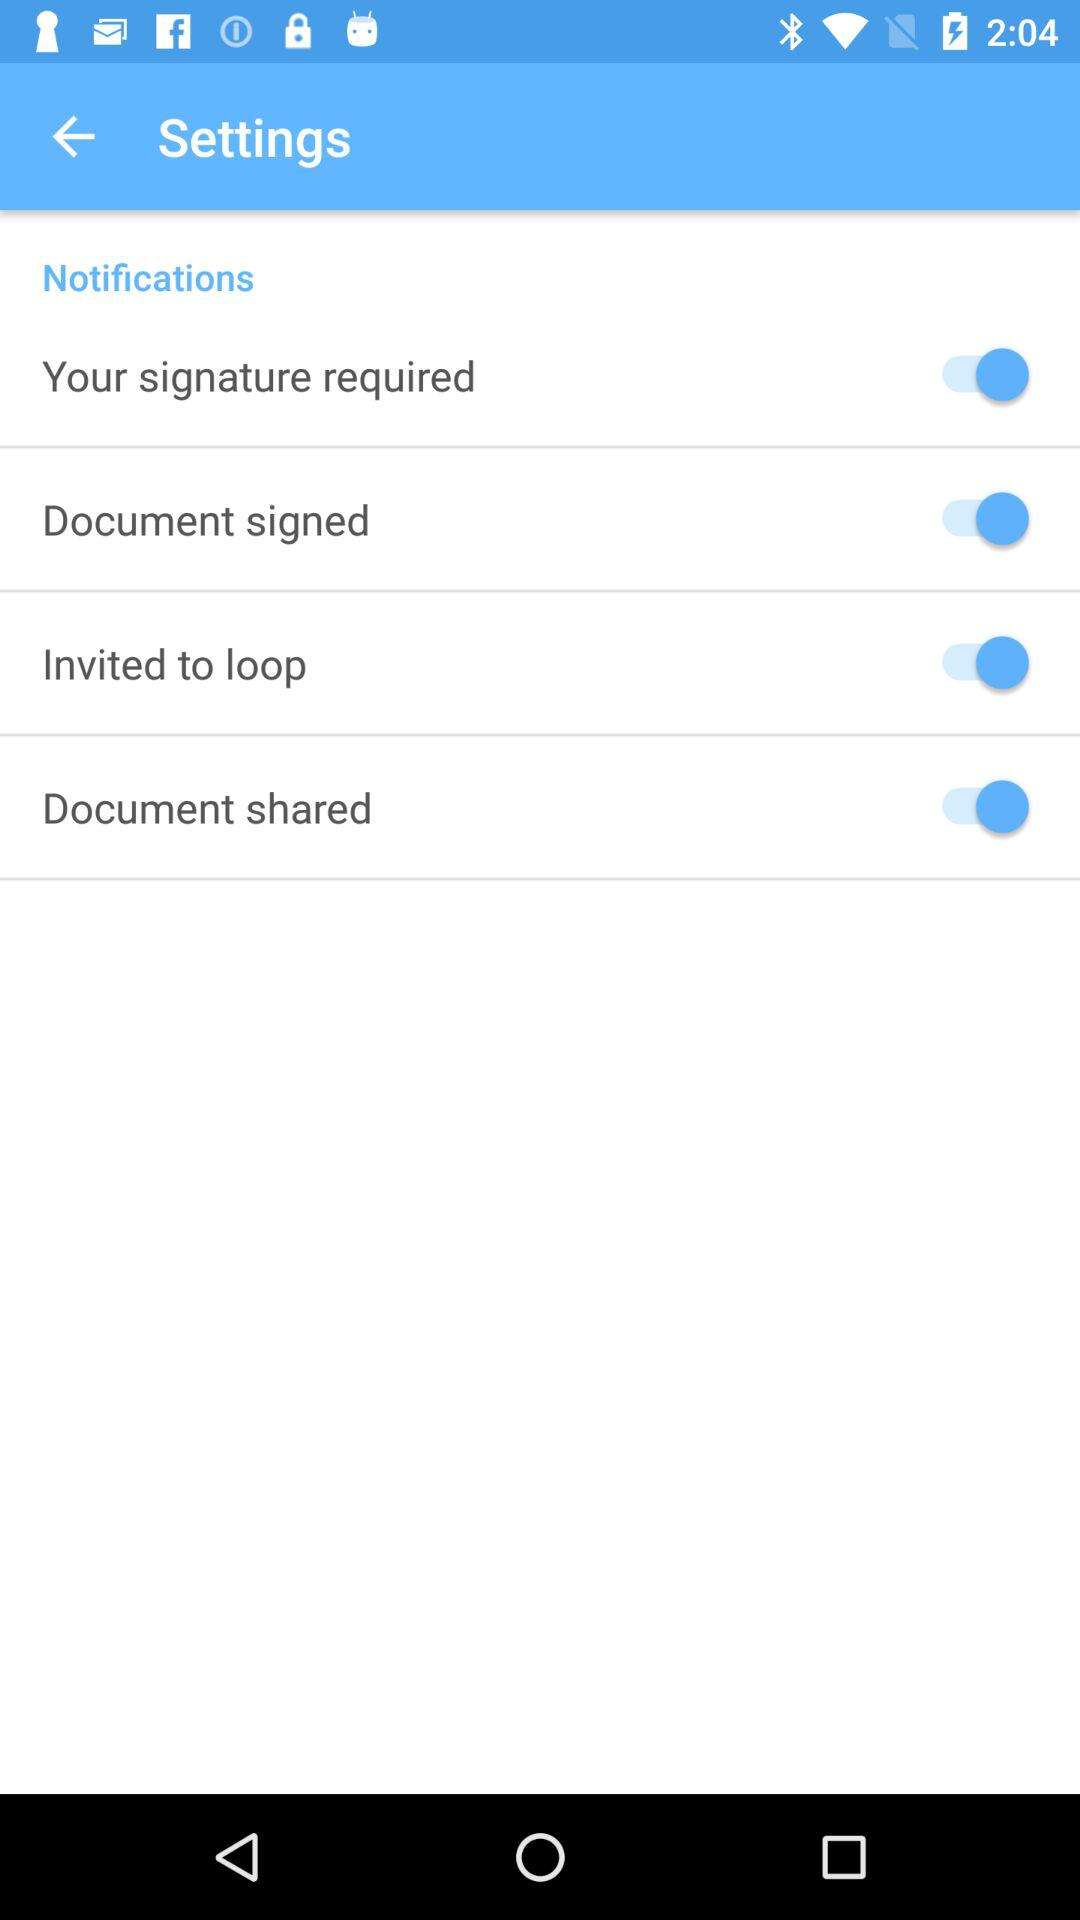What is the status of the "Invited to loop" switch? The status is "on". 